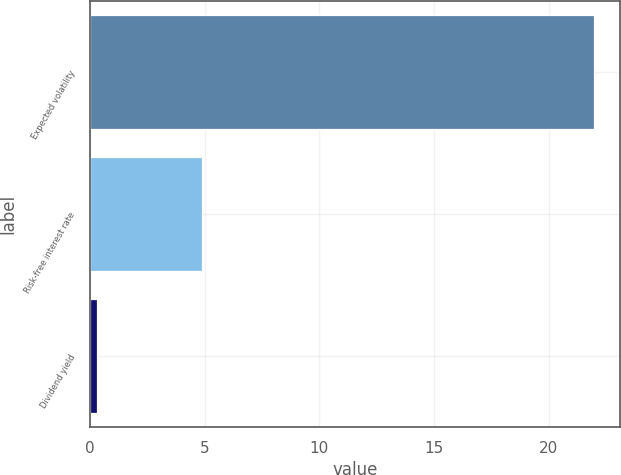Convert chart. <chart><loc_0><loc_0><loc_500><loc_500><bar_chart><fcel>Expected volatility<fcel>Risk-free interest rate<fcel>Dividend yield<nl><fcel>22<fcel>4.88<fcel>0.3<nl></chart> 